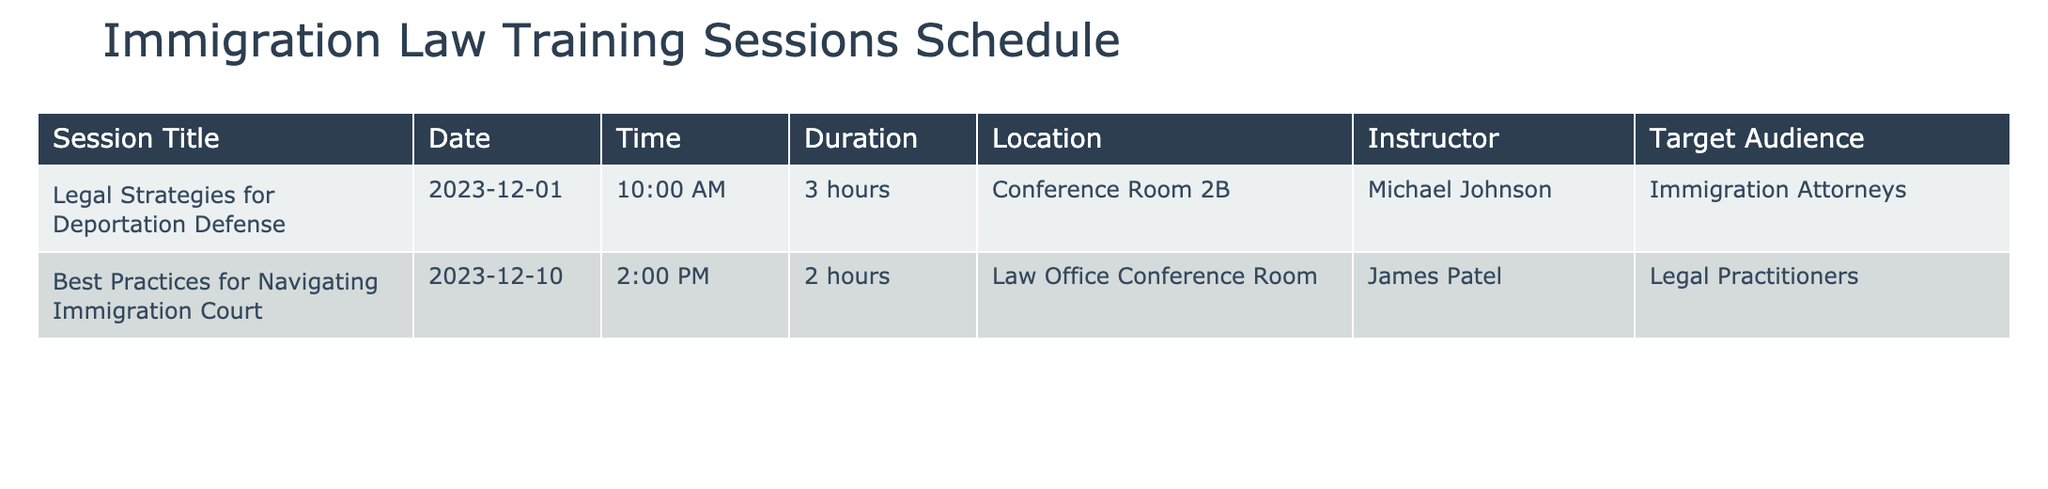What is the title of the session scheduled for December 10, 2023? The table lists the session titles along with their corresponding dates. By locating the date December 10, 2023, in the Date column, the title associated with this date is "Best Practices for Navigating Immigration Court."
Answer: Best Practices for Navigating Immigration Court How long is the session conducted by Michael Johnson? The table specifies the duration of each session along with the instructor’s name. By identifying the row where the instructor is Michael Johnson, I can see that the duration is noted as "3 hours."
Answer: 3 hours Is the session "Legal Strategies for Deportation Defense" aimed at immigration attorneys? Reviewing the Target Audience column, the entry for "Legal Strategies for Deportation Defense" shows that it is indeed targeted towards "Immigration Attorneys."
Answer: Yes What is the time difference between the two training sessions listed? The table provides the start times for each of the two sessions. The first session begins at 10:00 AM and the second at 2:00 PM. The difference in time is 4 hours (from 10:00 AM to 2:00 PM). Therefore, the time difference is 4 hours.
Answer: 4 hours How many total hours of training are offered in the sessions? From the Duration column, I can find that the first session lasts 3 hours and the second session lasts 2 hours. Summing these values gives a total of 3 + 2 = 5 hours of training offered.
Answer: 5 hours What is the location of the session led by James Patel? To find the location, I locate the row where James Patel is listed as the instructor. The Location for this session, "Best Practices for Navigating Immigration Court," is noted as "Law Office Conference Room."
Answer: Law Office Conference Room Are both sessions aimed at legal practitioners? I need to evaluate both sessions in the Target Audience column. The first session (Michael Johnson) targets "Immigration Attorneys," while the second (James Patel) targets "Legal Practitioners." Since "Legal Practitioners" and "Immigration Attorneys" are not the same, the answer is no.
Answer: No Which instructor is responsible for the session with the shortest duration? I compare the durations of both sessions. Michael Johnson's session lasts 3 hours and James Patel's session lasts 2 hours. Therefore, James Patel, leading the 2-hour session, is the one responsible for the session with the shortest duration.
Answer: James Patel What is the earliest training session date listed? By looking at the Date column directly, I see the two dates are December 1, 2023, and December 10, 2023. Clearly, December 1, 2023, is the earliest date listed for a training session.
Answer: December 1, 2023 